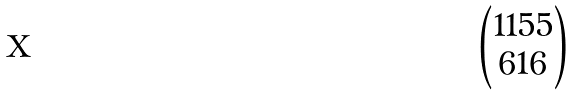<formula> <loc_0><loc_0><loc_500><loc_500>\begin{pmatrix} 1 1 5 5 \\ 6 1 6 \end{pmatrix}</formula> 